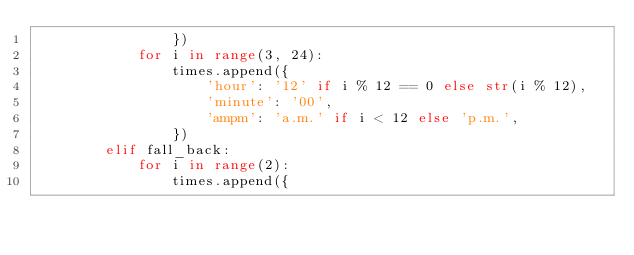Convert code to text. <code><loc_0><loc_0><loc_500><loc_500><_Python_>                })
            for i in range(3, 24):
                times.append({
                    'hour': '12' if i % 12 == 0 else str(i % 12),
                    'minute': '00',
                    'ampm': 'a.m.' if i < 12 else 'p.m.',
                })
        elif fall_back:
            for i in range(2):
                times.append({</code> 